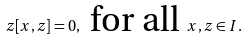Convert formula to latex. <formula><loc_0><loc_0><loc_500><loc_500>z [ x , z ] = 0 , \text { for all } x , z \in I .</formula> 